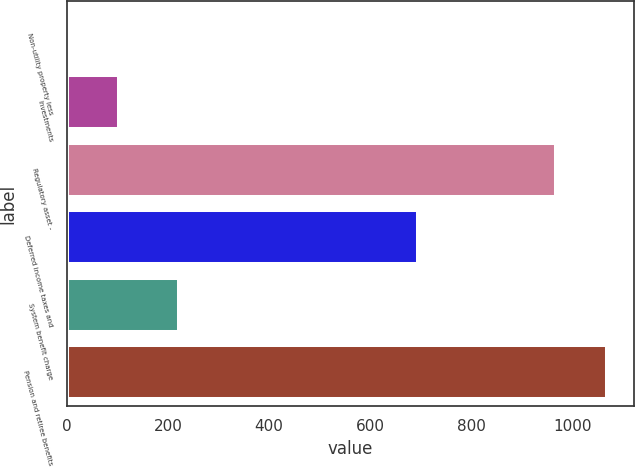Convert chart. <chart><loc_0><loc_0><loc_500><loc_500><bar_chart><fcel>Non-utility property less<fcel>Investments<fcel>Regulatory asset -<fcel>Deferred income taxes and<fcel>System benefit charge<fcel>Pension and retiree benefits<nl><fcel>1<fcel>103<fcel>967<fcel>695<fcel>221<fcel>1069<nl></chart> 